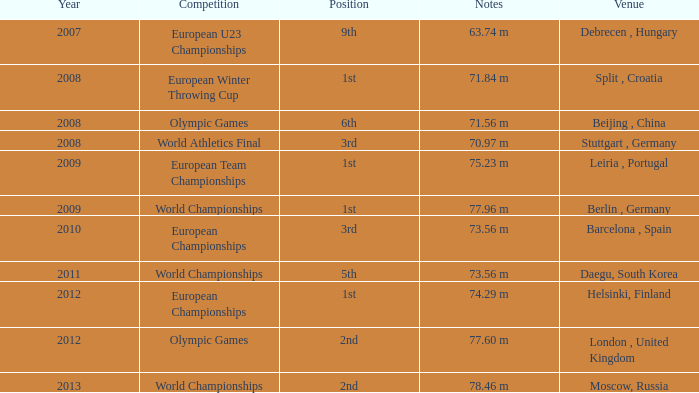Which Year has a Position of 9th? 2007.0. 